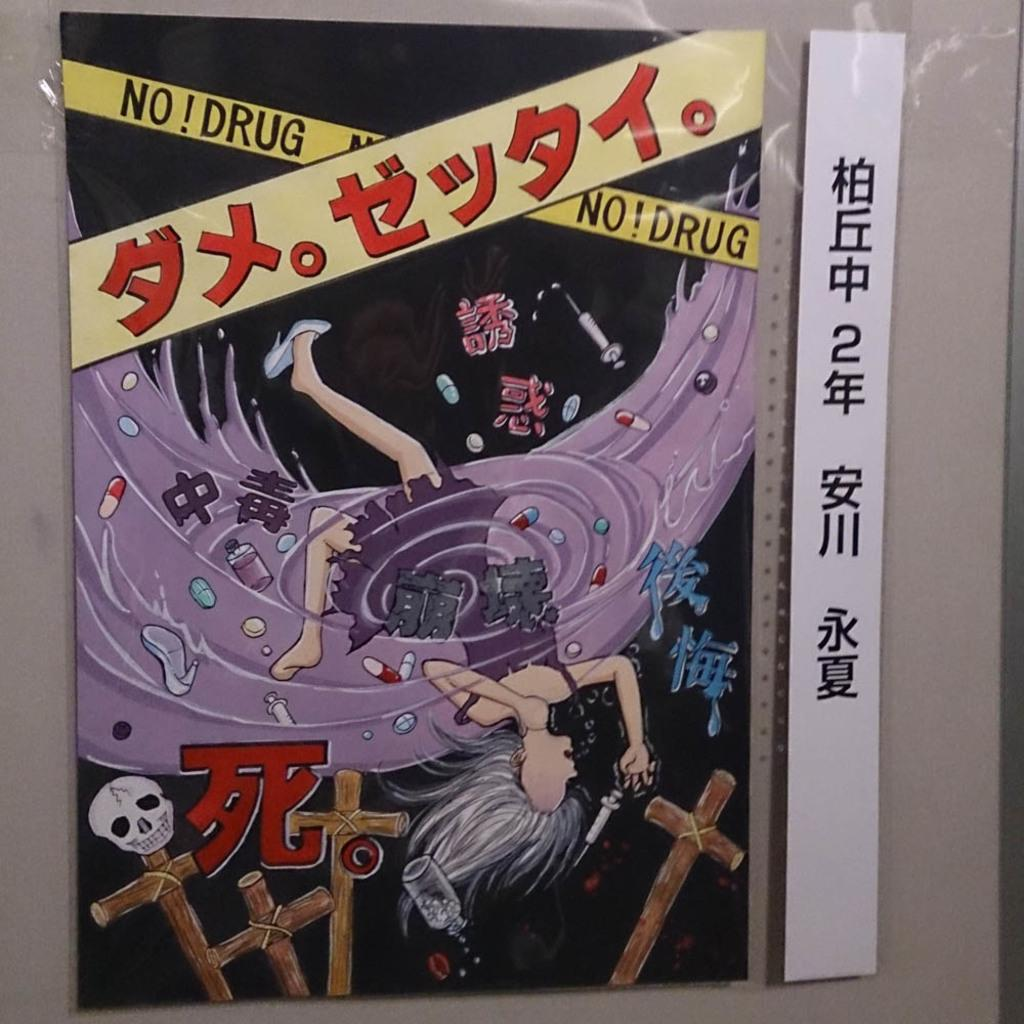<image>
Give a short and clear explanation of the subsequent image. A poster of a girl in a tsunami with some foreign promoting NO! Drug 